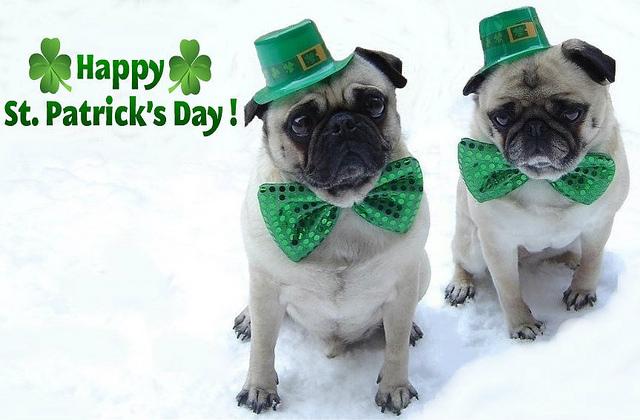What breed of dog is this?
Short answer required. Pug. What holiday is this image for?
Short answer required. St patrick's day. Do these animals look happy in their outfits?
Give a very brief answer. No. 